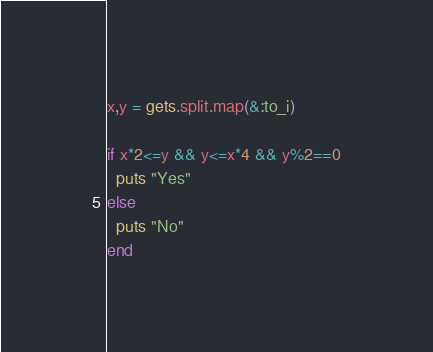<code> <loc_0><loc_0><loc_500><loc_500><_Ruby_>x,y = gets.split.map(&:to_i)

if x*2<=y && y<=x*4 && y%2==0
  puts "Yes"
else
  puts "No"
end
</code> 